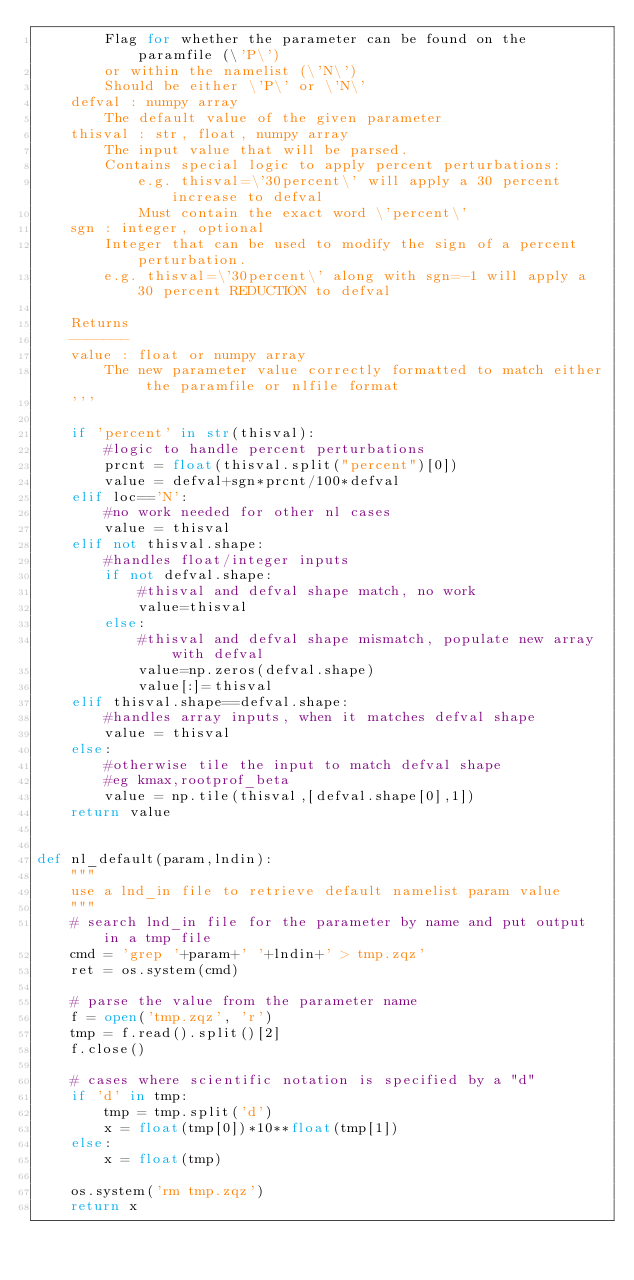<code> <loc_0><loc_0><loc_500><loc_500><_Python_>        Flag for whether the parameter can be found on the paramfile (\'P\') 
        or within the namelist (\'N\')
        Should be either \'P\' or \'N\'
    defval : numpy array
        The default value of the given parameter
    thisval : str, float, numpy array
        The input value that will be parsed.
        Contains special logic to apply percent perturbations:
            e.g. thisval=\'30percent\' will apply a 30 percent increase to defval
            Must contain the exact word \'percent\'
    sgn : integer, optional
        Integer that can be used to modify the sign of a percent perturbation.
        e.g. thisval=\'30percent\' along with sgn=-1 will apply a 30 percent REDUCTION to defval

    Returns
    -------
    value : float or numpy array
        The new parameter value correctly formatted to match either the paramfile or nlfile format
    '''

    if 'percent' in str(thisval):
        #logic to handle percent perturbations
        prcnt = float(thisval.split("percent")[0])
        value = defval+sgn*prcnt/100*defval
    elif loc=='N':
        #no work needed for other nl cases
        value = thisval
    elif not thisval.shape:
        #handles float/integer inputs
        if not defval.shape:
            #thisval and defval shape match, no work
            value=thisval
        else:
            #thisval and defval shape mismatch, populate new array with defval
            value=np.zeros(defval.shape)
            value[:]=thisval
    elif thisval.shape==defval.shape:
        #handles array inputs, when it matches defval shape
        value = thisval
    else:
        #otherwise tile the input to match defval shape
        #eg kmax,rootprof_beta
        value = np.tile(thisval,[defval.shape[0],1])
    return value


def nl_default(param,lndin):
    """
    use a lnd_in file to retrieve default namelist param value
    """ 
    # search lnd_in file for the parameter by name and put output in a tmp file
    cmd = 'grep '+param+' '+lndin+' > tmp.zqz'
    ret = os.system(cmd)

    # parse the value from the parameter name
    f = open('tmp.zqz', 'r')
    tmp = f.read().split()[2]
    f.close()

    # cases where scientific notation is specified by a "d"
    if 'd' in tmp:
        tmp = tmp.split('d')
        x = float(tmp[0])*10**float(tmp[1])
    else:
        x = float(tmp)
        
    os.system('rm tmp.zqz')   
    return x
</code> 